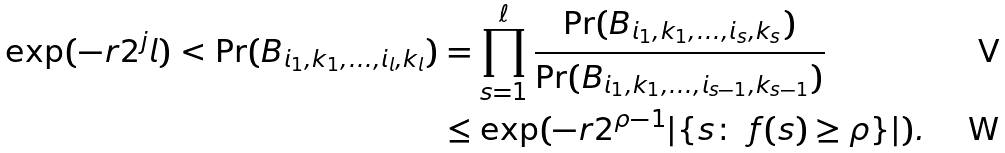Convert formula to latex. <formula><loc_0><loc_0><loc_500><loc_500>\exp ( - r 2 ^ { j } l ) < \Pr ( B _ { i _ { 1 } , k _ { 1 } , \dots , i _ { l } , k _ { l } } ) & = \prod _ { s = 1 } ^ { \ell } \frac { \Pr ( B _ { i _ { 1 } , k _ { 1 } , \dots , i _ { s } , k _ { s } } ) } { \Pr ( B _ { i _ { 1 } , k _ { 1 } , \dots , i _ { s - 1 } , k _ { s - 1 } } ) } \\ & \leq \exp ( - r 2 ^ { \rho - 1 } | \{ s \colon \ f ( s ) \geq \rho \} | ) .</formula> 